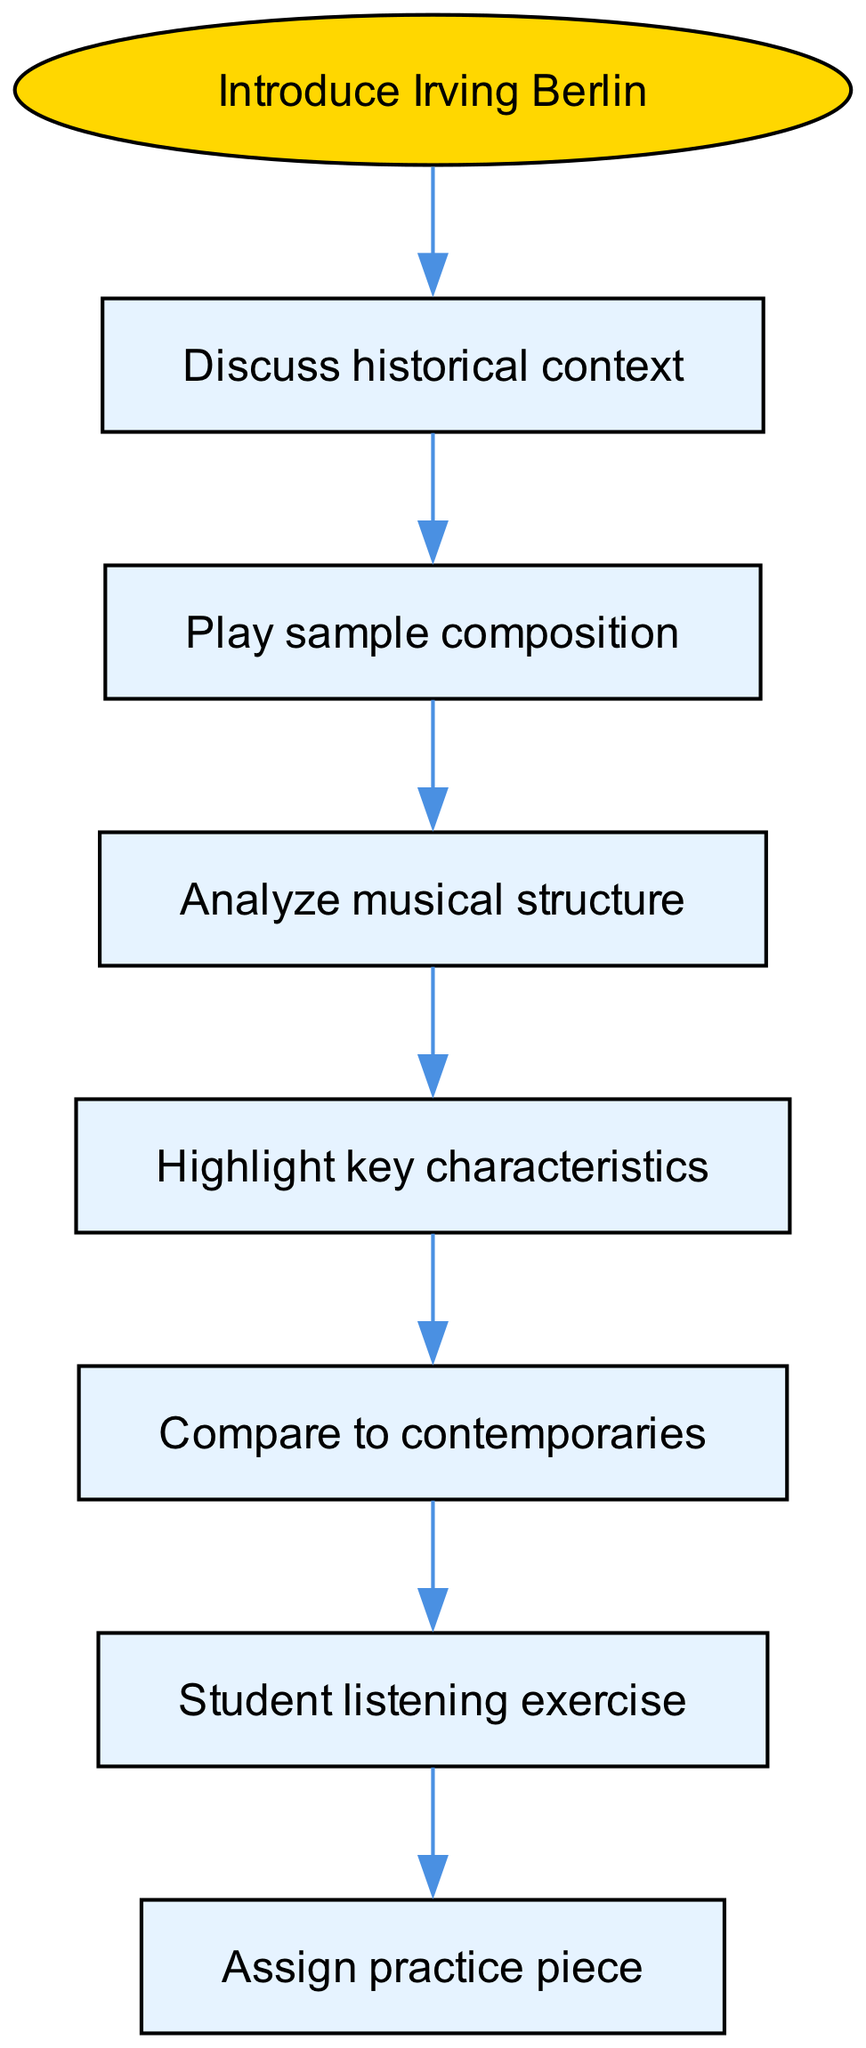What is the starting point of the lesson structure? The diagram indicates that the lesson structure begins with the node labeled "Introduce Irving Berlin." This is shown clearly as the first node from which all other nodes branch out.
Answer: Introduce Irving Berlin How many nodes are present in the diagram? By counting each unique block or box in the diagram, we can see there are a total of 7 nodes: one start node and six additional nodes.
Answer: 7 What follows after "Discuss historical context"? The flow from the "Discuss historical context" node leads directly to the next node, which is "Play sample composition." This shows the sequence of learning activities.
Answer: Play sample composition What is the last step in the lesson structure? The final node in the flowchart is "Assign practice piece," which is indicated as the last activity that students will engage in after completing the previous steps.
Answer: Assign practice piece Which node immediately precedes the "Student listening exercise"? Looking at the flow of the diagram, "Compare to contemporaries" is the node that comes directly before "Student listening exercise," indicating a teaching method of comparison before listening.
Answer: Compare to contemporaries What key characteristic is highlighted in the lesson structure? The diagram suggests that after analyzing musical structure, students will learn to "Highlight key characteristics," emphasizing the importance of recognizing specific traits in Berlin's compositions.
Answer: Highlight key characteristics What type of exercise is assigned after "Student listening exercise"? Following "Student listening exercise," the next step in the diagram is "Assign practice piece," which details the next action that should be taken after the listening exercise.
Answer: Assign practice piece How does the lesson structure connect historical context and sample composition? In the diagram, there is a direct edge that connects "Discuss historical context" to "Play sample composition," showing that historical context serves as a prelude to playing the music.
Answer: Play sample composition What stage comes before analyzing the musical structure? The diagram shows that the stage before "Analyze musical structure" is "Play sample composition," reinforcing that listening precedes analysis in learning.
Answer: Play sample composition 